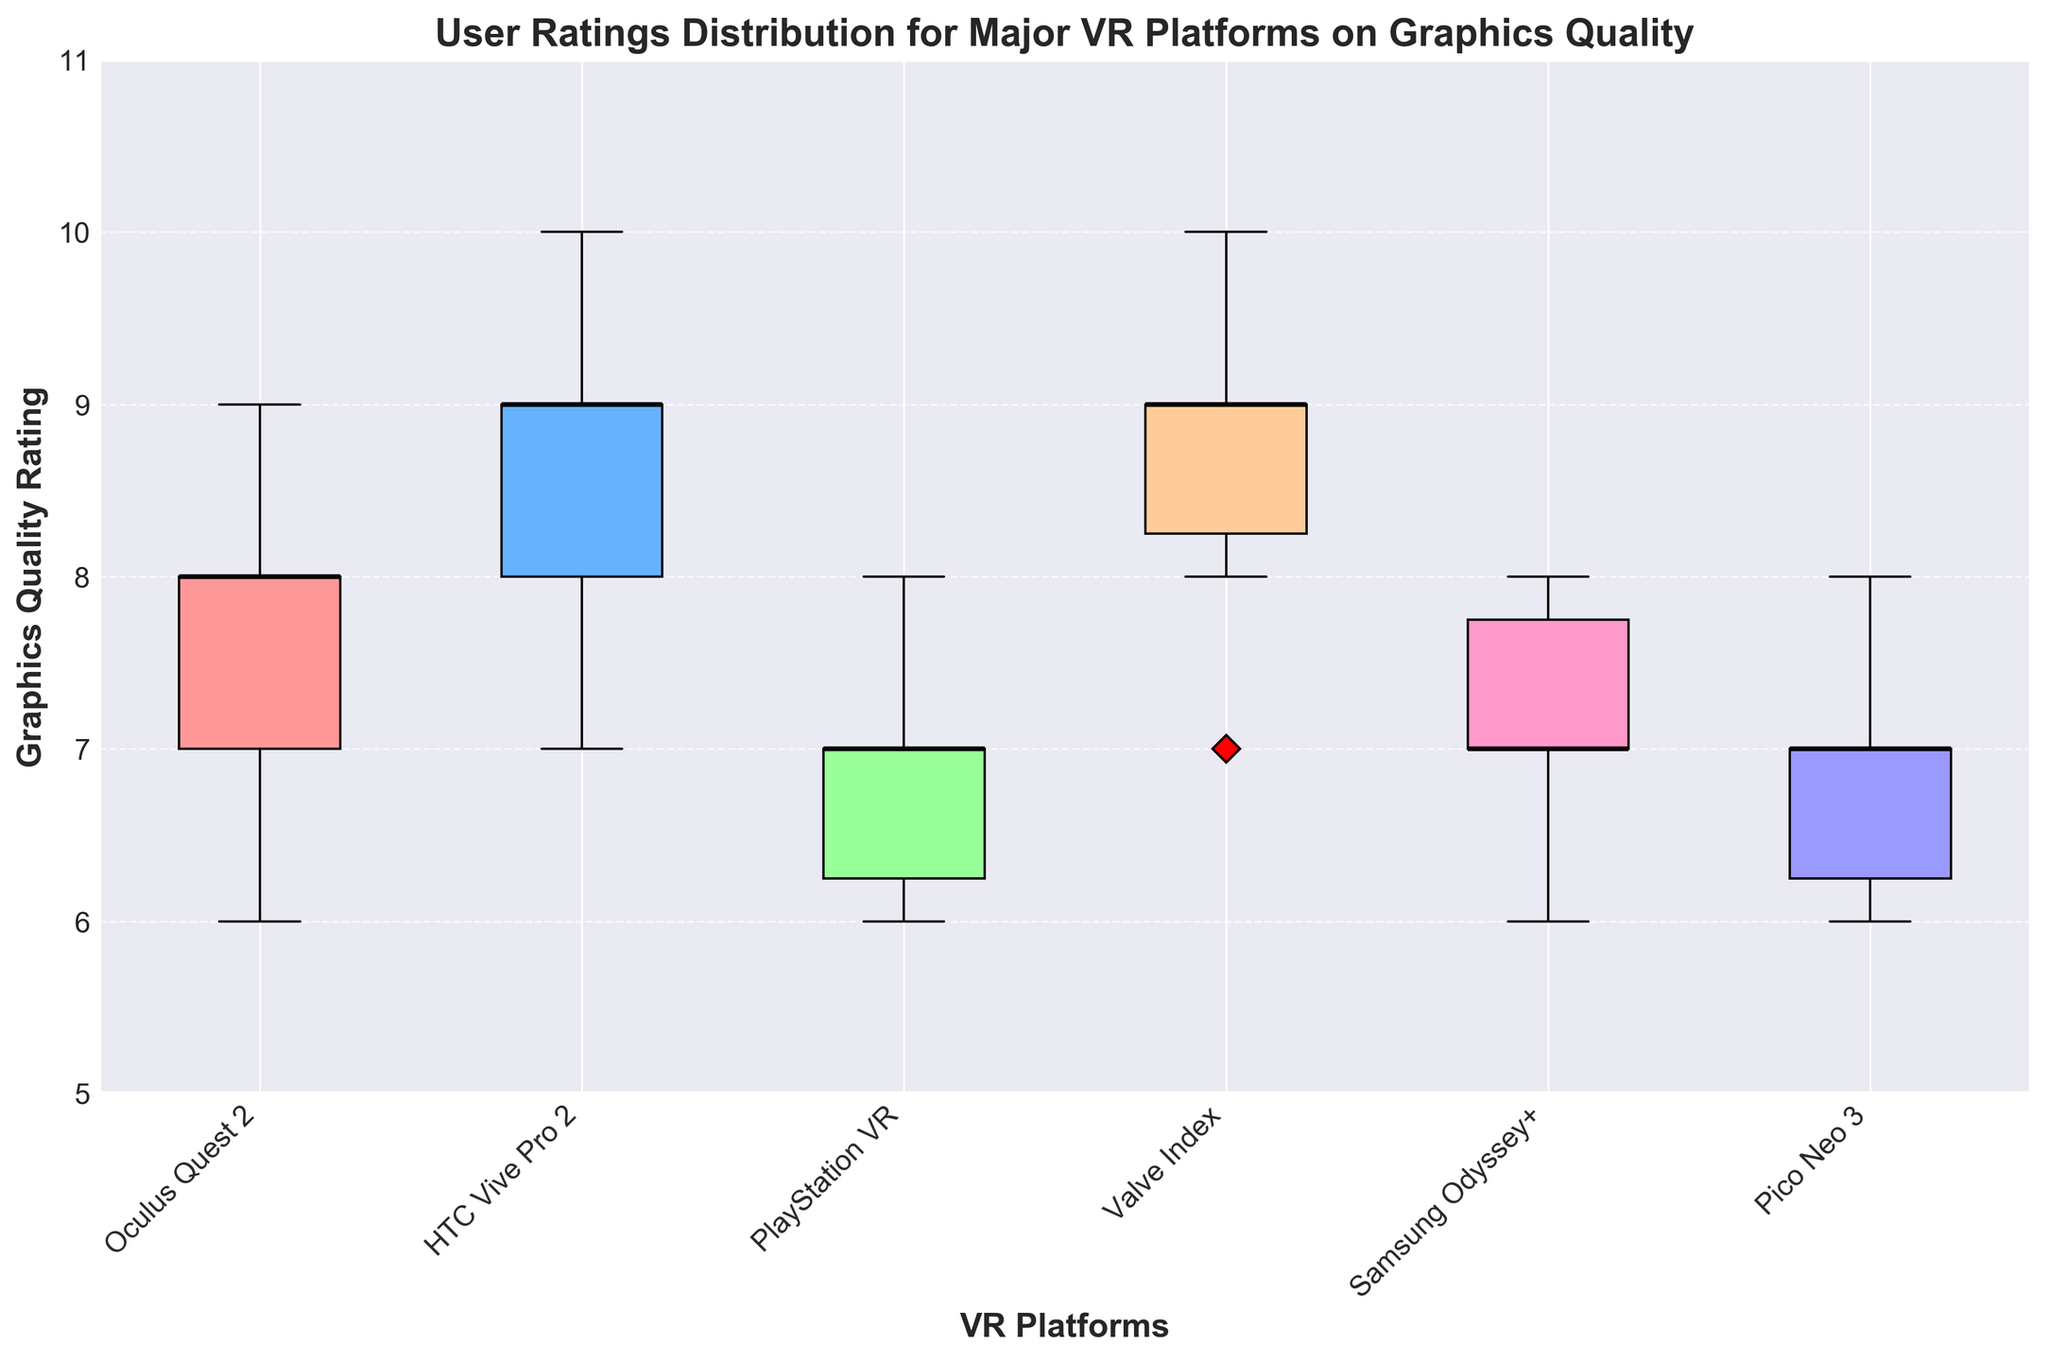What is the title of the box plot? The title is usually displayed at the top of a plot. In this figure, the title is clearly stated to provide an overview of what the plot is depicting.
Answer: User Ratings Distribution for Major VR Platforms on Graphics Quality What is the median rating for Oculus Quest 2? Look at the median line within the box for the Oculus Quest 2 box plot. It is the line that intersects the box horizontally.
Answer: 8 Which VR platform has the highest maximum rating? The highest maximum rating is identified by the topmost whisker or the farthest data point above the box in any of the box plots.
Answer: HTC Vive Pro 2 Which VR platform has the lowest rating and what is that rating? Find the platform whose box plot has the bottom-most whisker or data point below the box. Check the y-axis value aligned with that point.
Answer: PlayStation VR, 6 What are the interquartile ranges (IQR) of the Valve Index and Pico Neo 3? To find the IQR, subtract the value at the bottom end of the box (25th percentile) from the value at the top end of the box (75th percentile) for each platform’s box plot.
Answer: Valve Index: 9-8=1, Pico Neo 3: 7-6=1 Which platform has the most consistent (least spread out) user ratings based on the box plot? The platform with the smallest IQR (Interquartile Range) or the smallest distance between the lower and upper quartile (edges of the box) represents consistency.
Answer: Pico Neo 3 How does the median rating of PlayStation VR compare to HTC Vive Pro 2? Compare the median lines of both box plots. HTC Vive Pro 2's median is higher than PlayStation VR's.
Answer: HTC Vive Pro 2 has a higher median Is there any platform with an interquartile range (IQR) that spans across more than 2 units? The IQR is the distance between the 25th and 75th percentiles. Check if any of the platforms’ IQRs span more than 2 units on the y-axis.
Answer: No Which VR platform has the widest range of user ratings? Look for the box plot with the longest distance between the bottom and top whiskers. This shows the range from the minimum to the maximum ratings.
Answer: HTC Vive Pro 2 Do any platforms have outliers, and if so, which platforms and what are the outliers? Outliers in a box plot are often indicated as individual points outside the whiskers. Check each box plot for red diamonds (markers for outliers).
Answer: None 